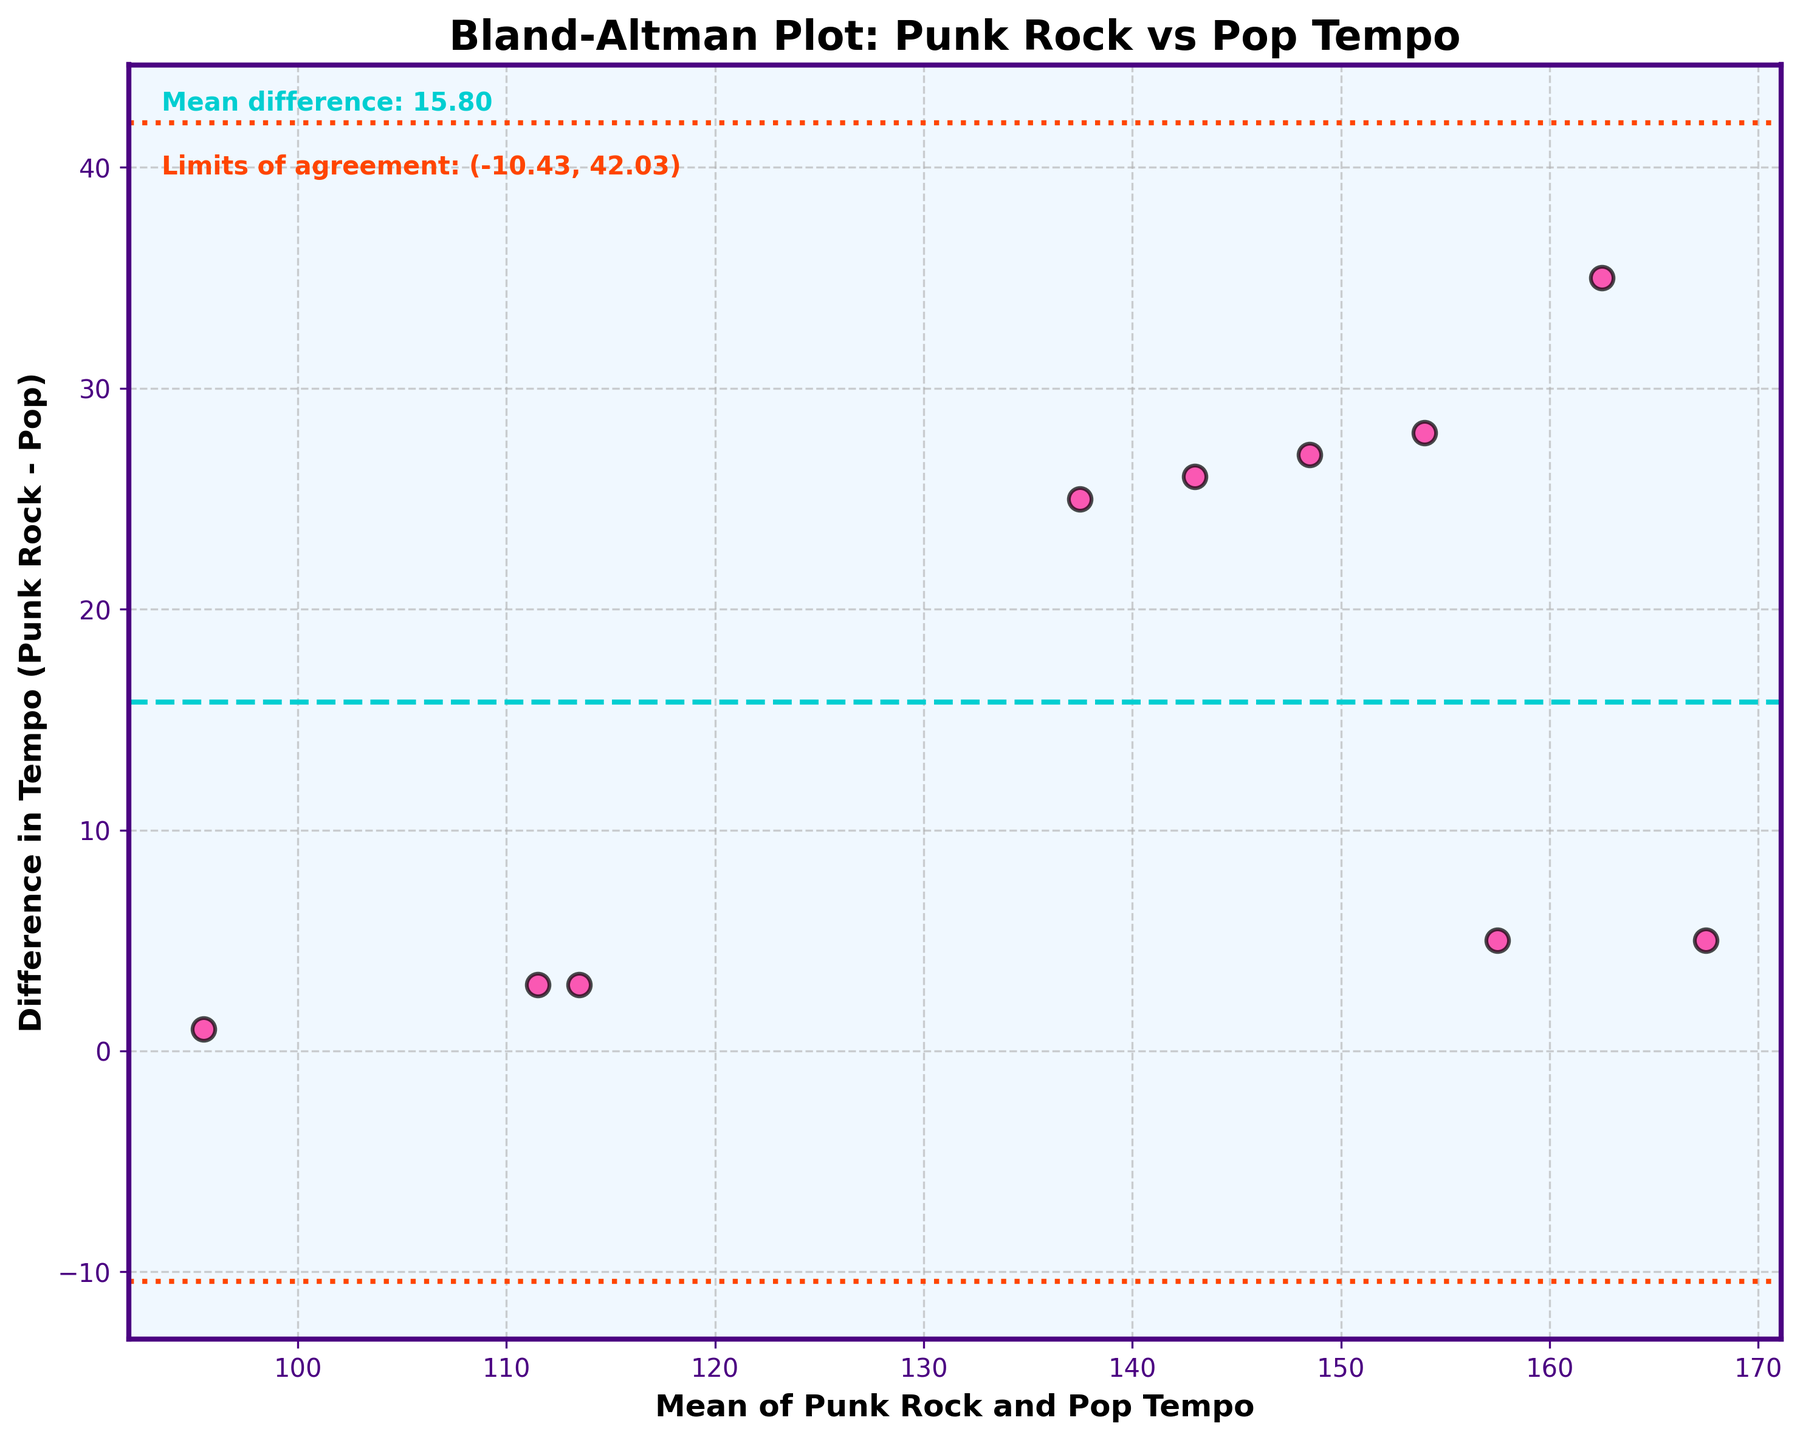what does the title of the plot indicate? The title of the plot reads "Bland-Altman Plot: Punk Rock vs Pop Tempo." This indicates that the plot is a Bland-Altman plot comparing the tempo of punk rock songs to mainstream pop songs.
Answer: Bland-Altman Plot: Punk Rock vs Pop Tempo How many data points are plotted in the figure? To determine the number of data points, count the distinct scatter points on the plot. Each point represents a pair of Punk Rock and Pop tempo data. From the song list, there are 10 songs in total, so there are 10 data points plotted.
Answer: 10 What are the axes labels of the plot? The x-axis label is "Mean of Punk Rock and Pop Tempo," and the y-axis label is "Difference in Tempo (Punk Rock - Pop)." These labels describe what each axis represents in the Bland-Altman plot.
Answer: Mean of Punk Rock and Pop Tempo (x-axis), Difference in Tempo (Punk Rock - Pop) (y-axis) What is the mean difference in tempo between punk rock and pop? According to the text on the plot, the mean difference in tempo between punk rock and pop is displayed. The teal-colored horizontal line also corresponds to this value. The value given is 14.10.
Answer: 14.10 What are the limits of agreement in the plot? The limits of agreement are written on the plot in red text and are also represented by the dotted lines on the plot. The limits are calculated as the mean difference ± 1.96 times the standard deviation of the differences. The value ranges given are (4.52, 23.68).
Answer: (4.52, 23.68) What is the tempo difference for "Blitzkrieg Bop" by Ramones? To find the tempo difference, locate the point that corresponds to "Blitzkrieg Bop" by Ramones. The plot shows the tempo difference on the y-axis. Since "Blitzkrieg Bop" is significantly above the mean line and nearer to the top limit of agreement, its difference is around 35.
Answer: Approximately 35 Which song has the smallest difference in tempo between punk rock and pop? To find this, look for the point closest to the x-axis (y=0), as this represents the smallest difference between punk rock and pop tempo. "Shape of You" by Ed Sheeran has the smallest tempo difference, which is around 1.
Answer: "Shape of You" by Ed Sheeran Is there any song where punk rock tempo is less than pop tempo? Look for points below the x-axis, where the difference (punk rock - pop) would be negative. No points are below the x-axis, indicating no punk rock songs have a tempo less than their pop equivalents.
Answer: No Which song has the highest mean tempo of punk rock and pop? The x-axis represents the mean tempo of punk rock and pop. Identify the rightmost point on the plot, as this should indicate the highest mean tempo. "Blitzkrieg Bop" by Ramones appears to have the highest mean tempo.
Answer: "Blitzkrieg Bop" by Ramones What does the coloration of the points indicate? The points are colored pink with black edges, which is purely for visual differentiation and does not communicate any additional specific information beyond being part of the dataset.
Answer: Points are visually differentiated in pink with black edges 